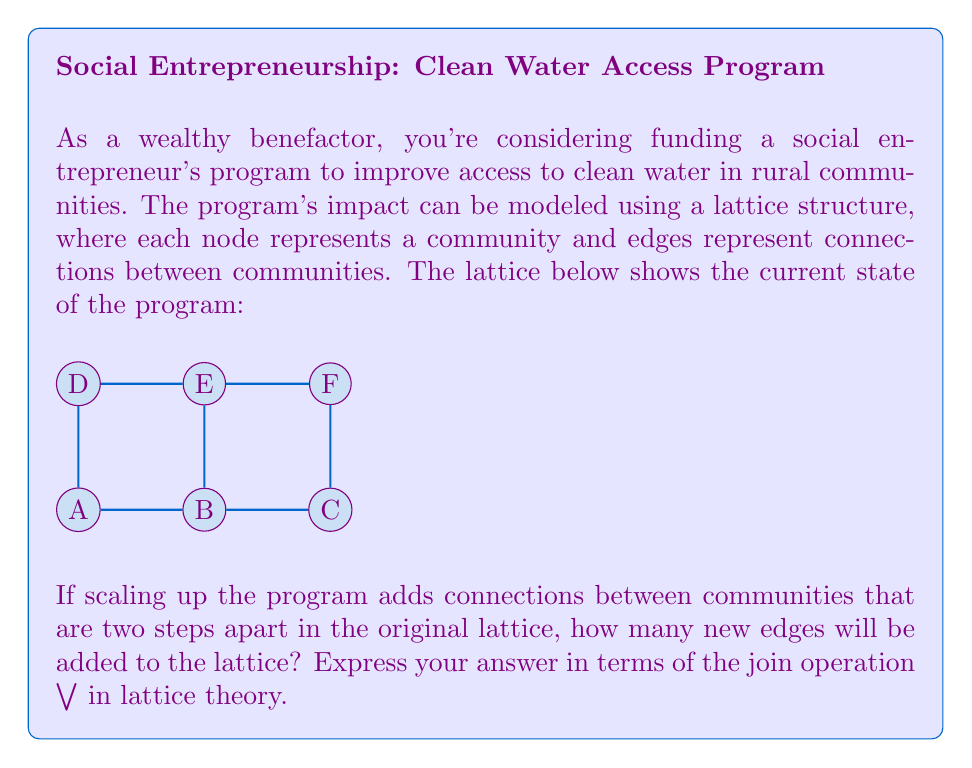What is the answer to this math problem? Let's approach this step-by-step:

1) First, we need to identify all pairs of nodes that are two steps apart in the original lattice:
   (A,C), (A,E), (B,D), (B,F), (C,E), (D,F)

2) In lattice theory, the join operation $$\vee$$ represents the least upper bound of two elements. In our context, it can be interpreted as creating a new connection between two nodes.

3) For each pair of nodes two steps apart, we'll use the join operation to represent the new edge:
   A $$\vee$$ C, A $$\vee$$ E, B $$\vee$$ D, B $$\vee$$ F, C $$\vee$$ E, D $$\vee$$ F

4) However, we need to be careful not to double-count edges. For example, A $$\vee$$ C and C $$\vee$$ A represent the same edge.

5) In this case, all our joins are unique, so we don't need to eliminate any duplicates.

6) To count the total number of new edges, we sum up all these join operations:

   $$\sum (A \vee C + A \vee E + B \vee D + B \vee F + C \vee E + D \vee F)$$

7) This sum represents the total number of new edges added to the lattice when scaling up the program.
Answer: $$\sum (A \vee C + A \vee E + B \vee D + B \vee F + C \vee E + D \vee F)$$ 